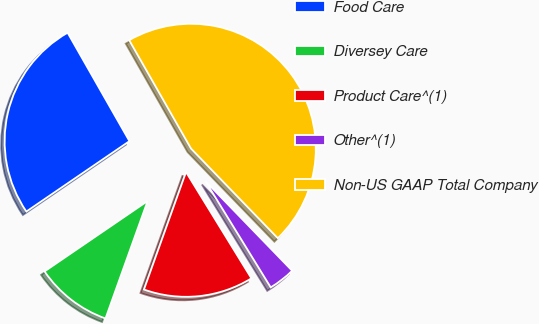Convert chart. <chart><loc_0><loc_0><loc_500><loc_500><pie_chart><fcel>Food Care<fcel>Diversey Care<fcel>Product Care^(1)<fcel>Other^(1)<fcel>Non-US GAAP Total Company<nl><fcel>26.29%<fcel>9.99%<fcel>14.25%<fcel>3.47%<fcel>46.01%<nl></chart> 